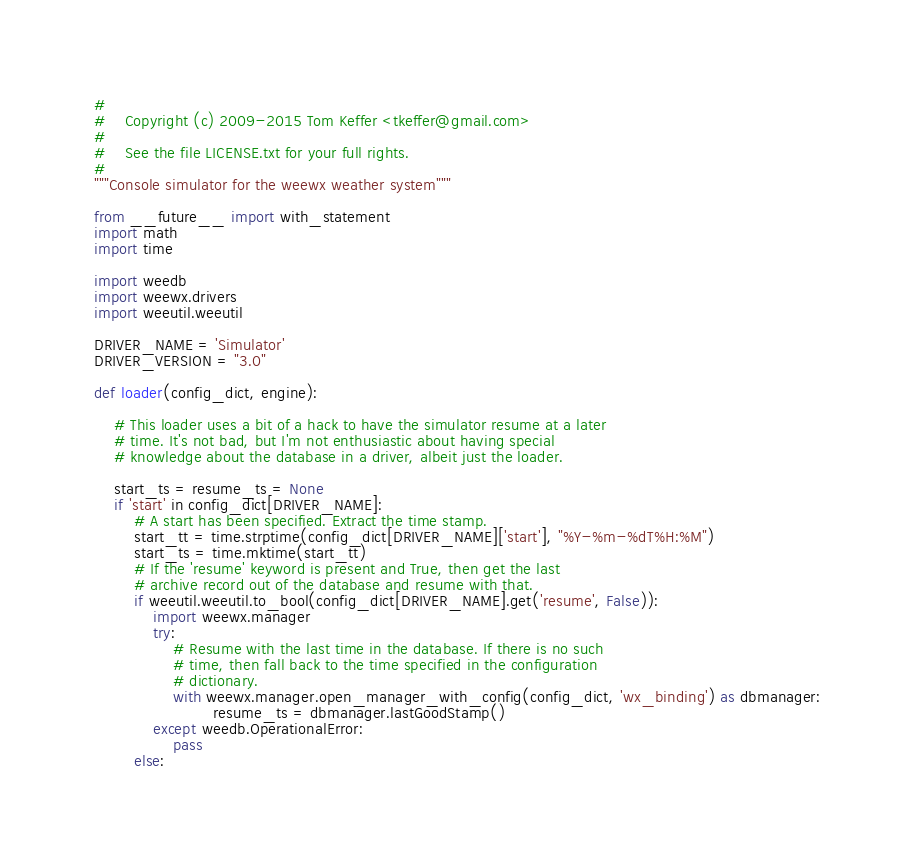Convert code to text. <code><loc_0><loc_0><loc_500><loc_500><_Python_>#
#    Copyright (c) 2009-2015 Tom Keffer <tkeffer@gmail.com>
#
#    See the file LICENSE.txt for your full rights.
#
"""Console simulator for the weewx weather system"""

from __future__ import with_statement
import math
import time

import weedb
import weewx.drivers
import weeutil.weeutil

DRIVER_NAME = 'Simulator'
DRIVER_VERSION = "3.0"

def loader(config_dict, engine):

    # This loader uses a bit of a hack to have the simulator resume at a later
    # time. It's not bad, but I'm not enthusiastic about having special
    # knowledge about the database in a driver, albeit just the loader.

    start_ts = resume_ts = None
    if 'start' in config_dict[DRIVER_NAME]:
        # A start has been specified. Extract the time stamp.
        start_tt = time.strptime(config_dict[DRIVER_NAME]['start'], "%Y-%m-%dT%H:%M")        
        start_ts = time.mktime(start_tt)
        # If the 'resume' keyword is present and True, then get the last
        # archive record out of the database and resume with that.
        if weeutil.weeutil.to_bool(config_dict[DRIVER_NAME].get('resume', False)):
            import weewx.manager
            try:
                # Resume with the last time in the database. If there is no such
                # time, then fall back to the time specified in the configuration
                # dictionary.
                with weewx.manager.open_manager_with_config(config_dict, 'wx_binding') as dbmanager:
                        resume_ts = dbmanager.lastGoodStamp()
            except weedb.OperationalError:
                pass
        else:</code> 